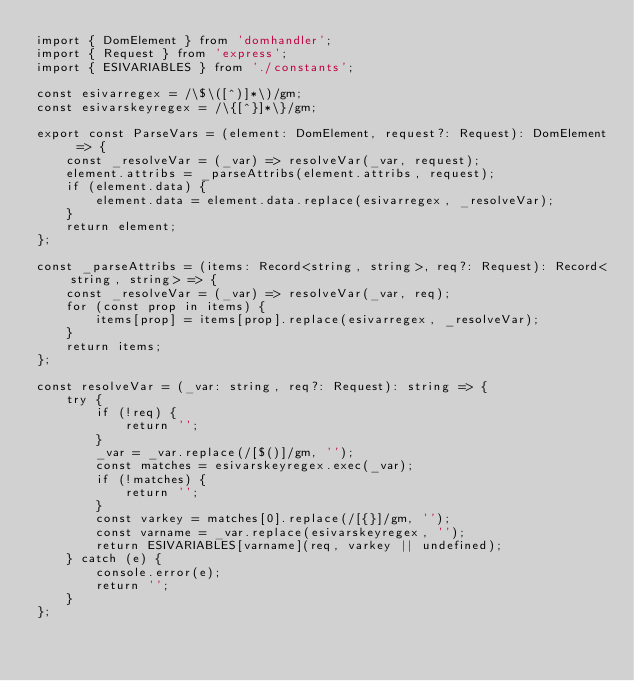Convert code to text. <code><loc_0><loc_0><loc_500><loc_500><_TypeScript_>import { DomElement } from 'domhandler';
import { Request } from 'express';
import { ESIVARIABLES } from './constants';

const esivarregex = /\$\([^)]*\)/gm;
const esivarskeyregex = /\{[^}]*\}/gm;

export const ParseVars = (element: DomElement, request?: Request): DomElement => {
    const _resolveVar = (_var) => resolveVar(_var, request);
    element.attribs = _parseAttribs(element.attribs, request);
    if (element.data) {
        element.data = element.data.replace(esivarregex, _resolveVar);
    }
    return element;
};

const _parseAttribs = (items: Record<string, string>, req?: Request): Record<string, string> => {
    const _resolveVar = (_var) => resolveVar(_var, req);
    for (const prop in items) {
        items[prop] = items[prop].replace(esivarregex, _resolveVar);
    }
    return items;
};

const resolveVar = (_var: string, req?: Request): string => {
    try {
        if (!req) {
            return '';
        }
        _var = _var.replace(/[$()]/gm, '');
        const matches = esivarskeyregex.exec(_var);
        if (!matches) {
            return '';
        }
        const varkey = matches[0].replace(/[{}]/gm, '');
        const varname = _var.replace(esivarskeyregex, '');
        return ESIVARIABLES[varname](req, varkey || undefined);
    } catch (e) {
        console.error(e);
        return '';
    }
};
</code> 